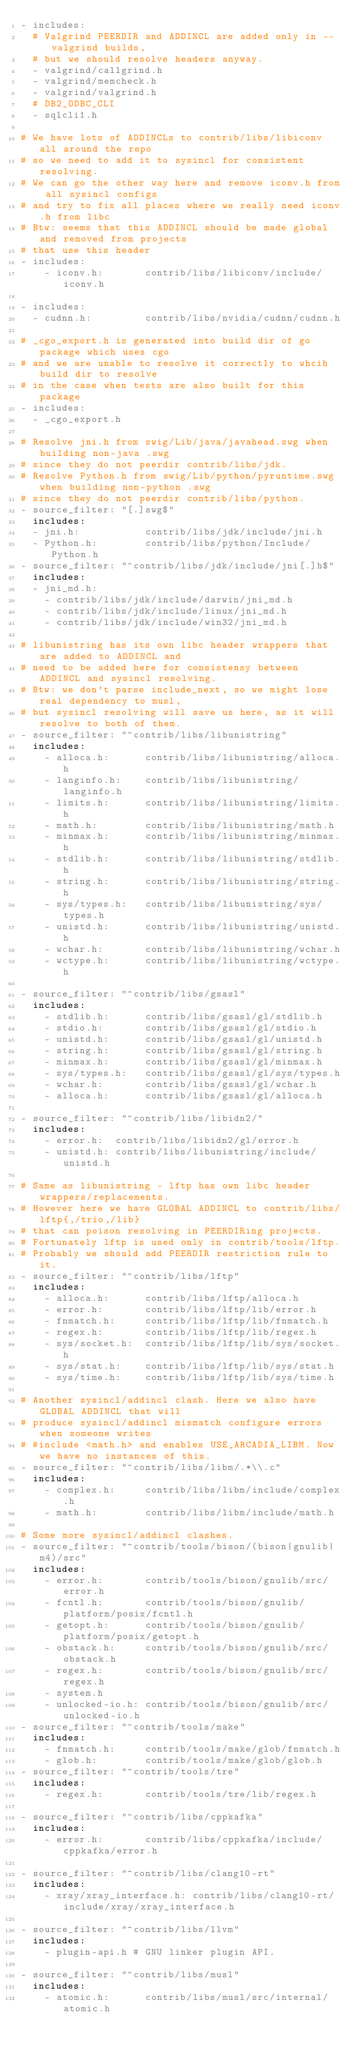<code> <loc_0><loc_0><loc_500><loc_500><_YAML_>- includes:
  # Valgrind PEERDIR and ADDINCL are added only in --valgrind builds,
  # but we should resolve headers anyway.
  - valgrind/callgrind.h
  - valgrind/memcheck.h
  - valgrind/valgrind.h
  # DB2_ODBC_CLI
  - sqlcli1.h

# We have lots of ADDINCLs to contrib/libs/libiconv all around the repo
# so we need to add it to sysincl for consistent resolving.
# We can go the other way here and remove iconv.h from all sysincl configs
# and try to fix all places where we really need iconv.h from libc
# Btw: seems that this ADDINCL should be made global and removed from projects
# that use this header
- includes:
    - iconv.h:       contrib/libs/libiconv/include/iconv.h

- includes:
  - cudnn.h:         contrib/libs/nvidia/cudnn/cudnn.h

# _cgo_export.h is generated into build dir of go package which uses cgo
# and we are unable to resolve it correctly to whcih build dir to resolve
# in the case when tests are also built for this package
- includes:
  - _cgo_export.h

# Resolve jni.h from swig/Lib/java/javahead.swg when building non-java .swg
# since they do not peerdir contrib/libs/jdk.
# Resolve Python.h from swig/Lib/python/pyruntime.swg when building non-python .swg
# since they do not peerdir contrib/libs/python.
- source_filter: "[.]swg$"
  includes:
  - jni.h:           contrib/libs/jdk/include/jni.h
  - Python.h:        contrib/libs/python/Include/Python.h
- source_filter: "^contrib/libs/jdk/include/jni[.]h$"
  includes:
  - jni_md.h:
    - contrib/libs/jdk/include/darwin/jni_md.h
    - contrib/libs/jdk/include/linux/jni_md.h
    - contrib/libs/jdk/include/win32/jni_md.h

# libunistring has its own libc header wrappers that are added to ADDINCL and
# need to be added here for consistensy between ADDINCL and sysincl resolving.
# Btw: we don't parse include_next, so we might lose real dependency to musl,
# but sysincl resolving will save us here, as it will resolve to both of them.
- source_filter: "^contrib/libs/libunistring"
  includes:
    - alloca.h:      contrib/libs/libunistring/alloca.h
    - langinfo.h:    contrib/libs/libunistring/langinfo.h
    - limits.h:      contrib/libs/libunistring/limits.h
    - math.h:        contrib/libs/libunistring/math.h
    - minmax.h:      contrib/libs/libunistring/minmax.h
    - stdlib.h:      contrib/libs/libunistring/stdlib.h
    - string.h:      contrib/libs/libunistring/string.h
    - sys/types.h:   contrib/libs/libunistring/sys/types.h
    - unistd.h:      contrib/libs/libunistring/unistd.h
    - wchar.h:       contrib/libs/libunistring/wchar.h
    - wctype.h:      contrib/libs/libunistring/wctype.h

- source_filter: "^contrib/libs/gsasl"
  includes:
    - stdlib.h:      contrib/libs/gsasl/gl/stdlib.h
    - stdio.h:       contrib/libs/gsasl/gl/stdio.h
    - unistd.h:      contrib/libs/gsasl/gl/unistd.h
    - string.h:      contrib/libs/gsasl/gl/string.h
    - minmax.h:      contrib/libs/gsasl/gl/minmax.h
    - sys/types.h:   contrib/libs/gsasl/gl/sys/types.h
    - wchar.h:       contrib/libs/gsasl/gl/wchar.h
    - alloca.h:      contrib/libs/gsasl/gl/alloca.h

- source_filter: "^contrib/libs/libidn2/"
  includes:
    - error.h:  contrib/libs/libidn2/gl/error.h
    - unistd.h: contrib/libs/libunistring/include/unistd.h

# Same as libunistring - lftp has own libc header wrappers/replacements.
# However here we have GLOBAL ADDINCL to contrib/libs/lftp{,/trio,/lib}
# that can poison resolving in PEERDIRing projects.
# Fortunately lftp is used only in contrib/tools/lftp.
# Probably we should add PEERDIR restriction rule to it.
- source_filter: "^contrib/libs/lftp"
  includes:
    - alloca.h:      contrib/libs/lftp/alloca.h
    - error.h:       contrib/libs/lftp/lib/error.h
    - fnmatch.h:     contrib/libs/lftp/lib/fnmatch.h
    - regex.h:       contrib/libs/lftp/lib/regex.h
    - sys/socket.h:  contrib/libs/lftp/lib/sys/socket.h
    - sys/stat.h:    contrib/libs/lftp/lib/sys/stat.h
    - sys/time.h:    contrib/libs/lftp/lib/sys/time.h

# Another sysincl/addincl clash. Here we also have GLOBAL ADDINCL that will
# produce sysincl/addincl mismatch configure errors when someone writes
# #include <math.h> and enables USE_ARCADIA_LIBM. Now we have no instances of this.
- source_filter: "^contrib/libs/libm/.*\\.c"
  includes:
    - complex.h:     contrib/libs/libm/include/complex.h
    - math.h:        contrib/libs/libm/include/math.h

# Some more sysincl/addincl clashes.
- source_filter: "^contrib/tools/bison/(bison|gnulib|m4)/src"
  includes:
    - error.h:       contrib/tools/bison/gnulib/src/error.h
    - fcntl.h:       contrib/tools/bison/gnulib/platform/posix/fcntl.h
    - getopt.h:      contrib/tools/bison/gnulib/platform/posix/getopt.h
    - obstack.h:     contrib/tools/bison/gnulib/src/obstack.h
    - regex.h:       contrib/tools/bison/gnulib/src/regex.h
    - system.h
    - unlocked-io.h: contrib/tools/bison/gnulib/src/unlocked-io.h
- source_filter: "^contrib/tools/make"
  includes:
    - fnmatch.h:     contrib/tools/make/glob/fnmatch.h
    - glob.h:        contrib/tools/make/glob/glob.h
- source_filter: "^contrib/tools/tre"
  includes:
    - regex.h:       contrib/tools/tre/lib/regex.h

- source_filter: "^contrib/libs/cppkafka"
  includes:
    - error.h:       contrib/libs/cppkafka/include/cppkafka/error.h

- source_filter: "^contrib/libs/clang10-rt"
  includes:
    - xray/xray_interface.h: contrib/libs/clang10-rt/include/xray/xray_interface.h

- source_filter: "^contrib/libs/llvm"
  includes:
    - plugin-api.h # GNU linker plugin API.

- source_filter: "^contrib/libs/musl"
  includes:
    - atomic.h:      contrib/libs/musl/src/internal/atomic.h</code> 